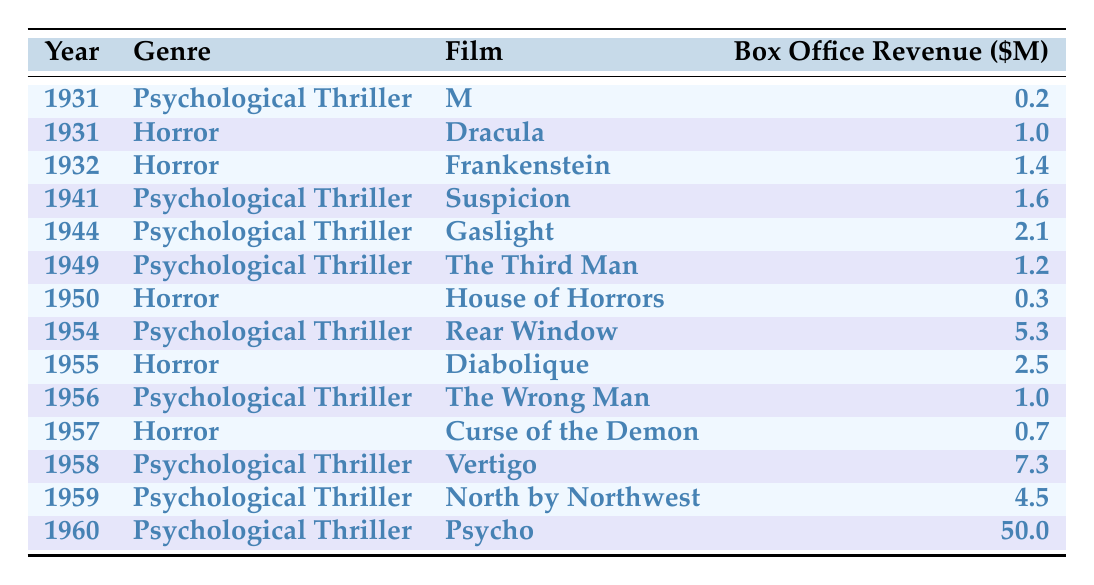What is the box office revenue of the film "Psycho" in 1960? The table shows that "Psycho" was released in 1960 and its box office revenue is listed as 50.0 million dollars.
Answer: 50.0 million dollars Which genre had the highest total box office revenue from 1930 to 1960? To determine the highest total box office revenue by genre, we sum the revenues for each genre. Psychological Thriller total is 70.0 (0.2 + 1.6 + 2.1 + 1.2 + 5.3 + 7.3 + 4.5 + 50.0) and Horror total is 6.9 (1.0 + 1.4 + 0.3 + 2.5 + 0.7). Psychological Thriller has a higher total.
Answer: Psychological Thriller In which year did the film "Rear Window" have its release? By checking the year associated with "Rear Window" in the table, we see it was released in 1954.
Answer: 1954 How many horror films listed had a box office revenue of less than 1 million dollars? There are two horror films with revenue less than 1 million: "House of Horrors" (0.3) and "Curse of the Demon" (0.7). Hence, the count is 2.
Answer: 2 Did "Frankenstein" earn more than "Dracula"? Comparing the box office revenues of "Frankenstein" (1.4 million) and "Dracula" (1.0 million), it's clear that "Frankenstein" earned more.
Answer: Yes What is the average box office revenue for Psychological Thriller films? We have 8 Psychological Thrillers: 0.2, 1.6, 2.1, 1.2, 5.3, 7.3, 4.5, and 50.0. The sum is 70.0 million dollars, yielding an average of 70.0 / 8 = 8.75 million dollars.
Answer: 8.75 Which horror film had the highest box office revenue? Comparing the revenues of the horror films, "Diabolique" has the highest revenue at 2.5 million dollars, as no other horror film exceeds this value.
Answer: Diabolique What was the box office revenue for "The Wrong Man"? Referring to the table, "The Wrong Man" has a listed box office revenue of 1.0 million dollars.
Answer: 1.0 million dollars 